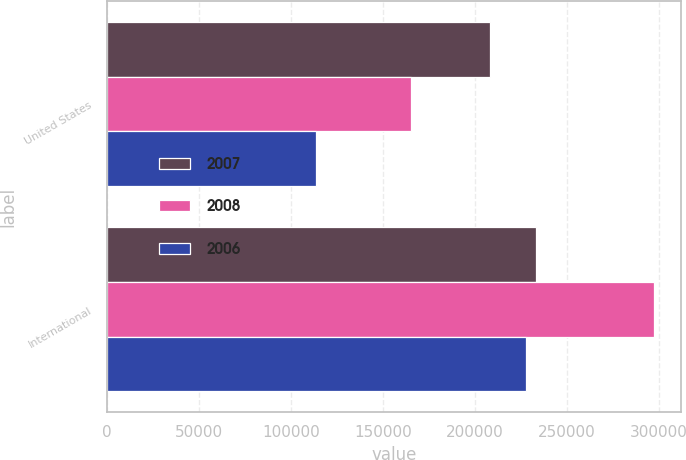<chart> <loc_0><loc_0><loc_500><loc_500><stacked_bar_chart><ecel><fcel>United States<fcel>International<nl><fcel>2007<fcel>208125<fcel>232930<nl><fcel>2008<fcel>165274<fcel>297108<nl><fcel>2006<fcel>113761<fcel>227713<nl></chart> 